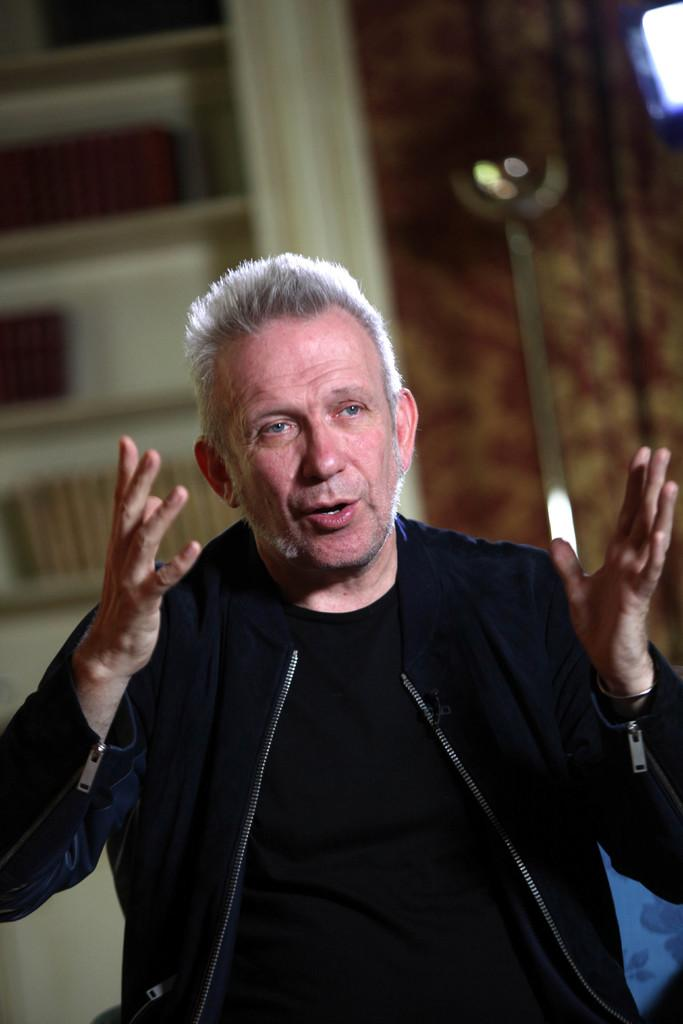Who is present in the image? There is a man in the image. Where is the man located? The man is in a room. What is the man wearing? The man is wearing a black dress. What can be seen on the walls of the room? There are shelves in the room. What type of window treatment is present in the room? There are curtains in the room. How many children are playing outside the window in the image? There are no children visible in the image, nor is there a window shown. 